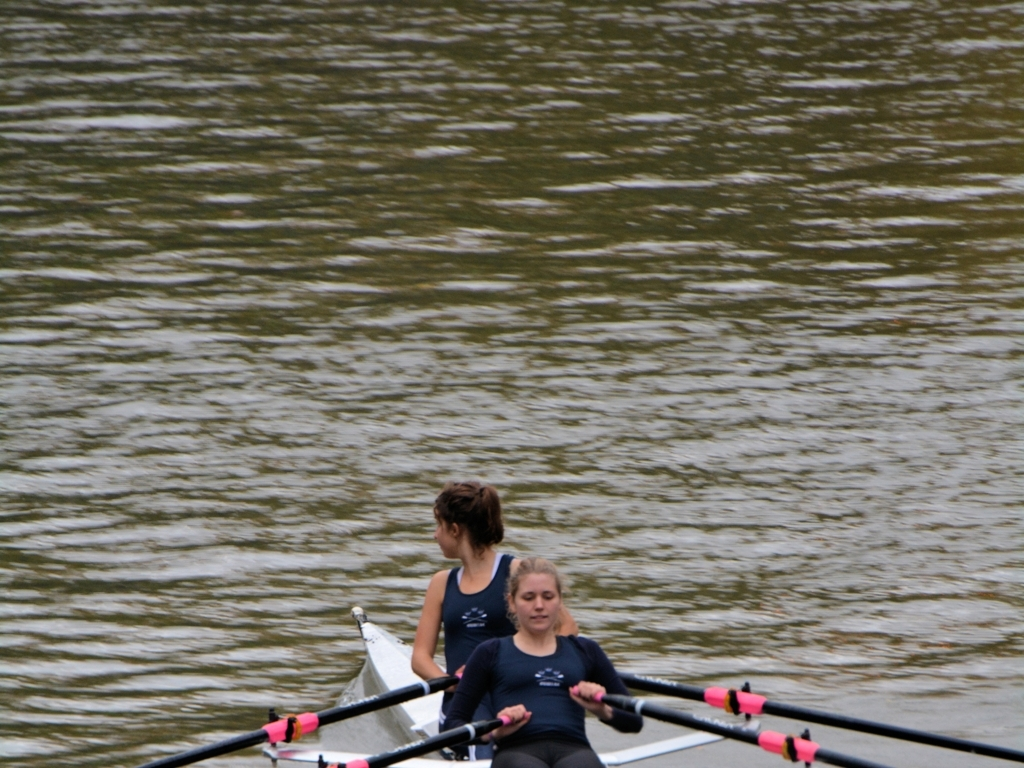Analyze the characteristics of the image and determine its quality based on your findings. The image displays a rowing scene with acceptable lighting that highlights the subjects, maintaining natural color vividness which enhances visual appeal. The main subjects, two athletes in a rowboat, are in clear focus, emphasizing their action and expressions, while the blurry water background provides a sense of motion. Compositionally, the image might benefit from a tighter framing to enhance the depiction of intensity and concentration in the sport. Additionally, adjusting the shutter speed could reduce the blurriness of the water, giving a crisper finish to the dynamic background. 